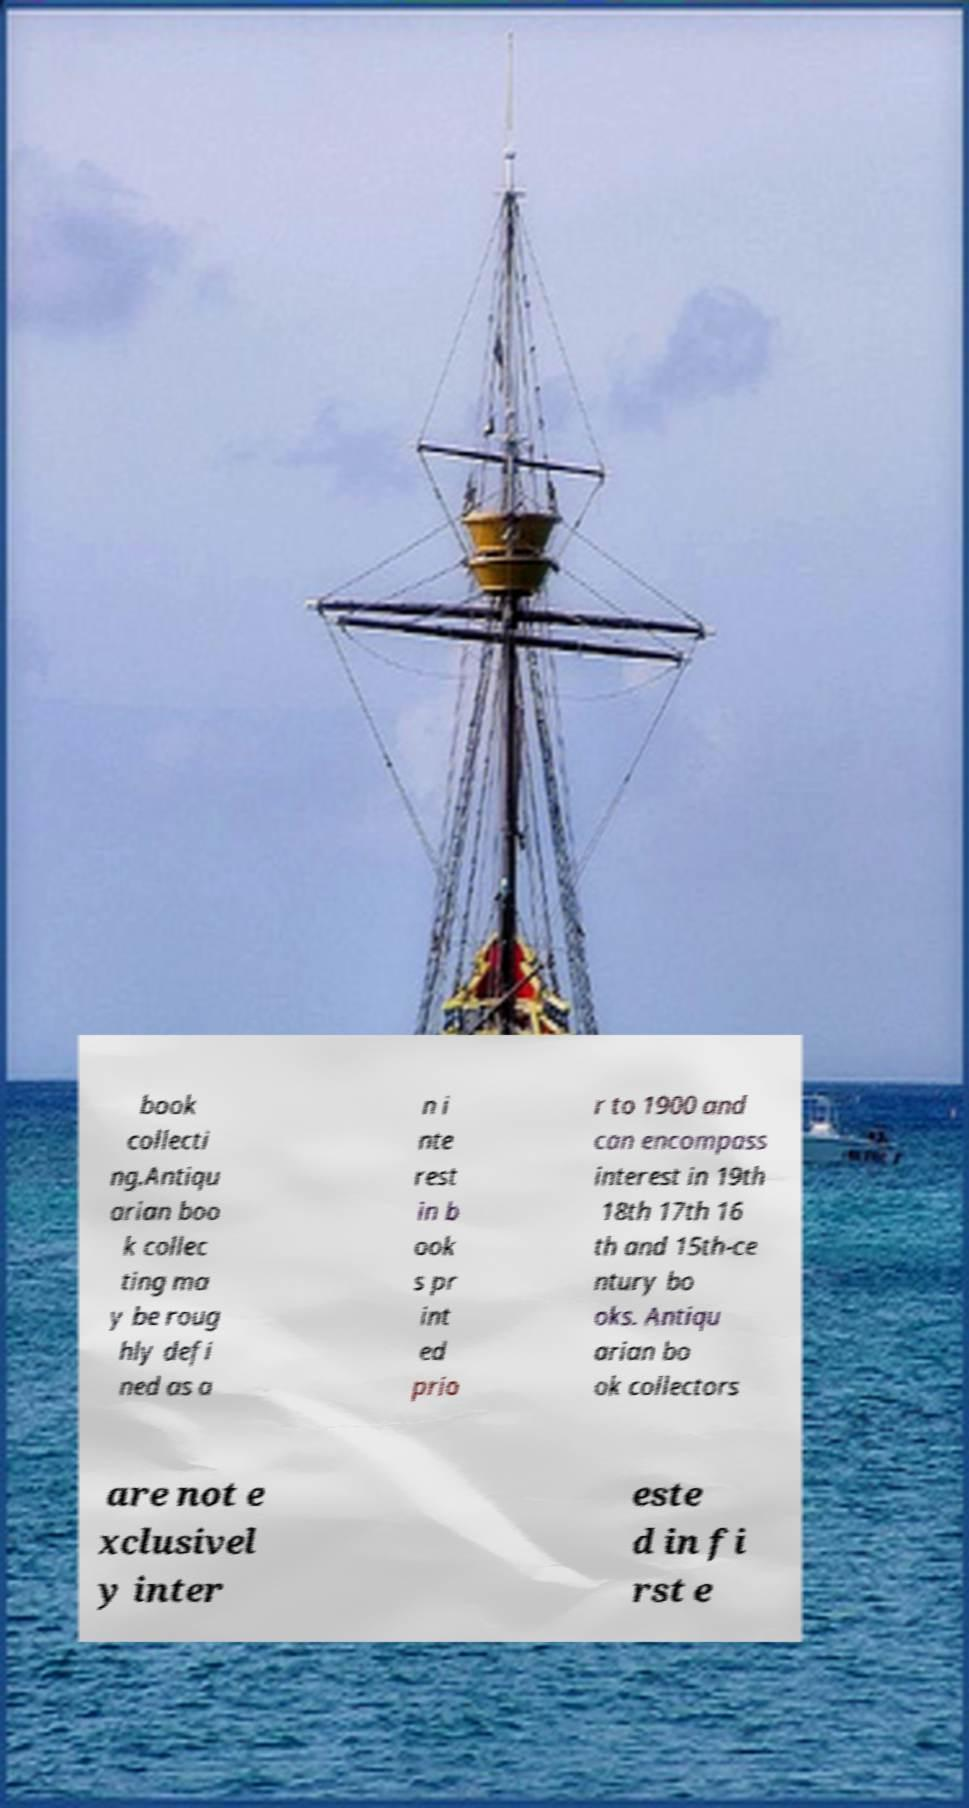What messages or text are displayed in this image? I need them in a readable, typed format. book collecti ng.Antiqu arian boo k collec ting ma y be roug hly defi ned as a n i nte rest in b ook s pr int ed prio r to 1900 and can encompass interest in 19th 18th 17th 16 th and 15th-ce ntury bo oks. Antiqu arian bo ok collectors are not e xclusivel y inter este d in fi rst e 